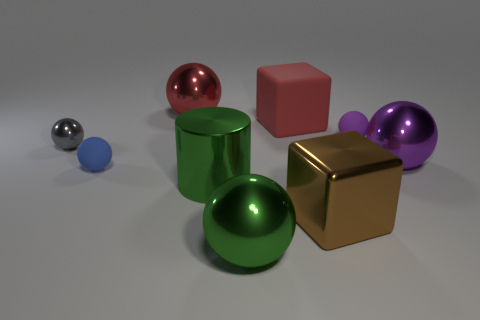Subtract all tiny blue balls. How many balls are left? 5 Subtract all blue spheres. How many spheres are left? 5 Subtract all balls. How many objects are left? 3 Add 1 large blue metallic cylinders. How many objects exist? 10 Subtract 2 balls. How many balls are left? 4 Subtract all purple cylinders. How many brown cubes are left? 1 Add 3 small matte things. How many small matte things are left? 5 Add 7 purple things. How many purple things exist? 9 Subtract 0 yellow spheres. How many objects are left? 9 Subtract all red spheres. Subtract all yellow blocks. How many spheres are left? 5 